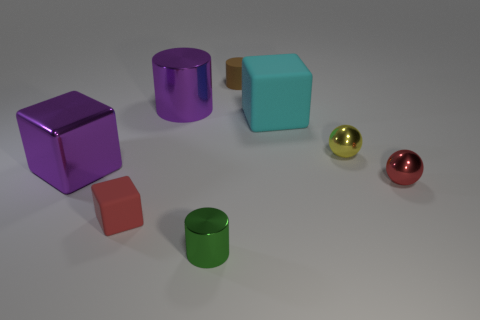Is the size of the matte cube that is to the right of the small brown cylinder the same as the rubber cube that is to the left of the green object?
Give a very brief answer. No. Are there any brown rubber objects that are in front of the tiny metal sphere in front of the purple metal thing in front of the small yellow thing?
Offer a terse response. No. Is the number of shiny cubes behind the yellow object less than the number of tiny green metallic cylinders to the left of the purple cube?
Your response must be concise. No. There is a small yellow object that is the same material as the big purple cylinder; what shape is it?
Your answer should be very brief. Sphere. What is the size of the object to the left of the rubber block that is on the left side of the tiny cylinder in front of the large purple cube?
Provide a succinct answer. Large. Are there more brown cylinders than green metallic spheres?
Your answer should be compact. Yes. There is a big cube on the left side of the large shiny cylinder; is it the same color as the big shiny object that is to the right of the tiny red cube?
Make the answer very short. Yes. Is the material of the small thing that is on the left side of the green metallic thing the same as the small cylinder that is behind the tiny green metal cylinder?
Provide a short and direct response. Yes. What number of red metal spheres are the same size as the brown rubber thing?
Make the answer very short. 1. Are there fewer purple shiny objects than red shiny objects?
Provide a short and direct response. No. 